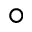<formula> <loc_0><loc_0><loc_500><loc_500>^ { \circ }</formula> 